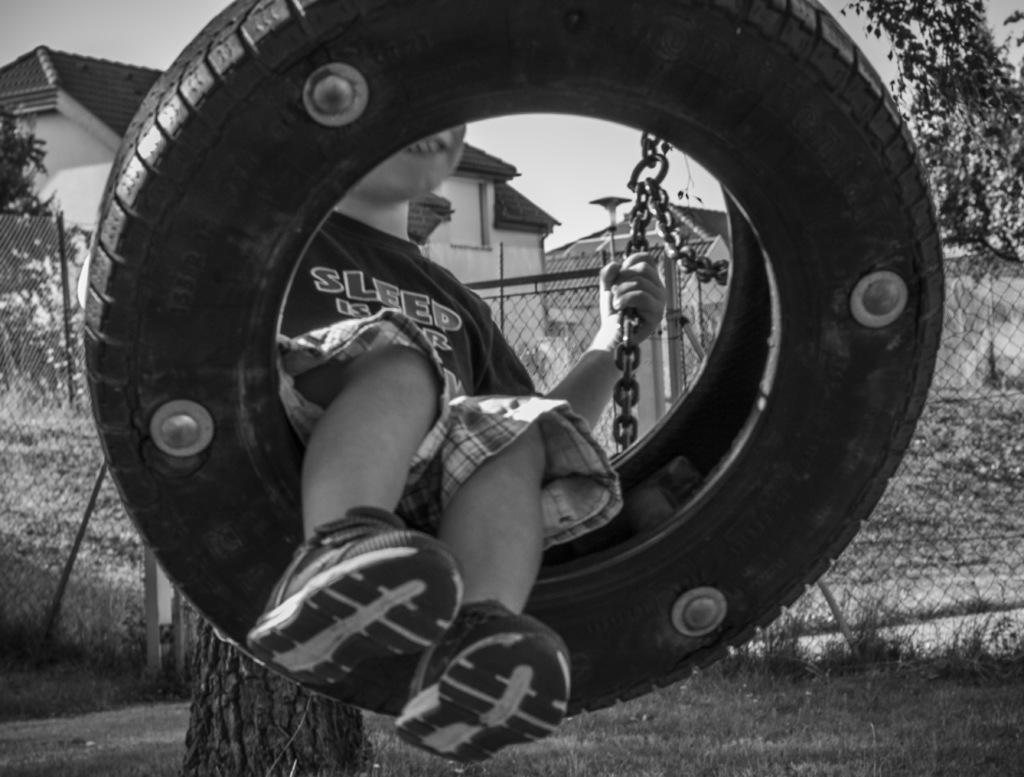What is the main subject of the picture? The main subject of the picture is a kid. Where is the kid located in the image? The kid is in a swing in the center of the picture. What is the kid holding in the image? The kid is holding the chain of the swing. What can be seen in the background of the image? There are trees, fencing, grass, a branch, and buildings in the background of the image. Is it raining in the image? There is no indication of rain in the image. Can you see a rake in the image? There is no rake present in the image. 